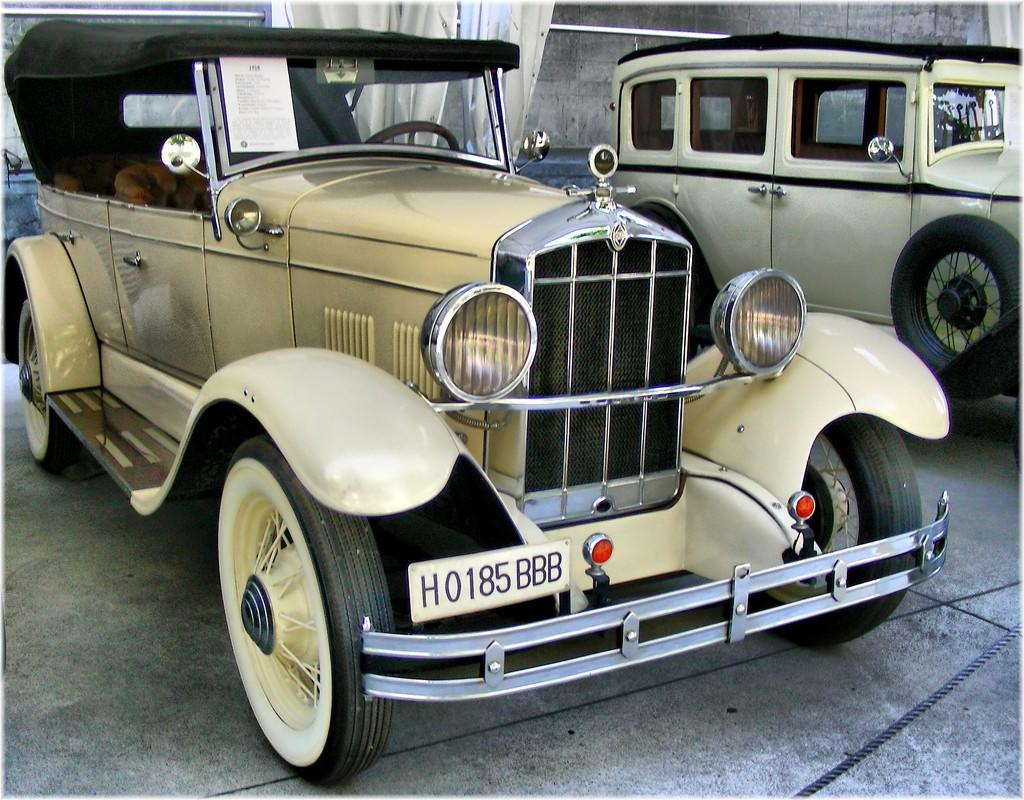What can be seen on the ground in the image? There are two vehicles on the ground in the image. What is visible in the background of the image? There is a wall in the background of the image. Are there any window treatments visible in the image? Yes, there are curtains on a metal rod in the background of the image. What type of story is being told by the bells in the image? There are no bells present in the image, so no story can be told by them. 